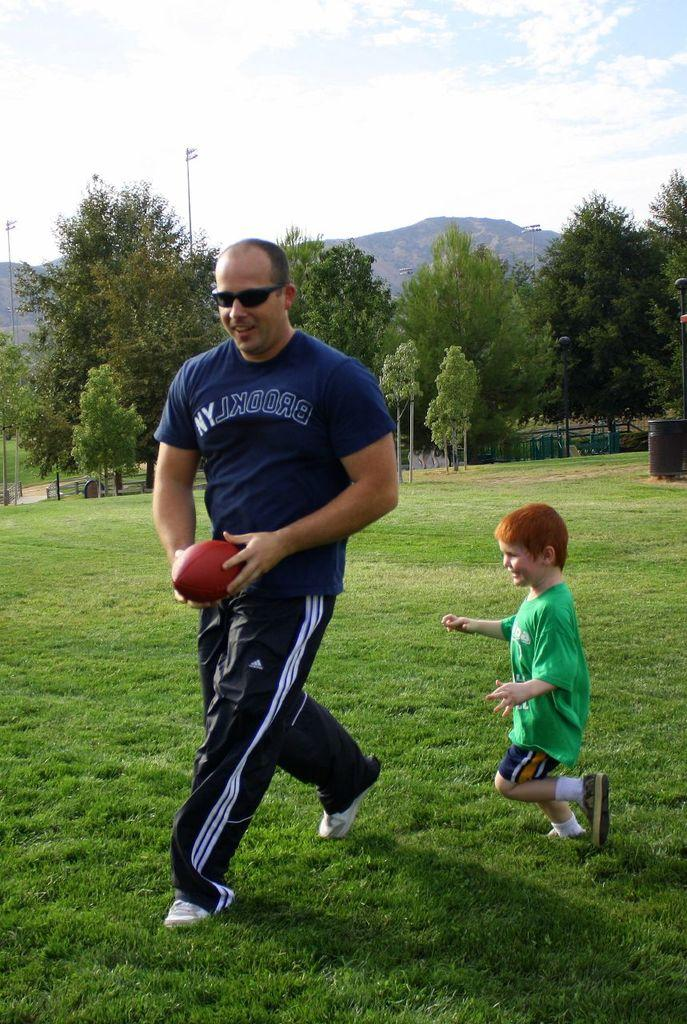What is the main subject in the center of the image? There is a man standing in the center of the image. What is the man holding in the image? The man is holding a ball. Who is beside the man in the image? There is a boy beside the man in the image. What can be seen in the background of the image? The sky with clouds, a mountain, and trees are visible in the background. How many spiders are crawling on the man's shoes in the image? There are no spiders visible on the man's shoes in the image. What type of bike is the boy riding in the image? There is no bike present in the image; the boy is standing beside the man. 